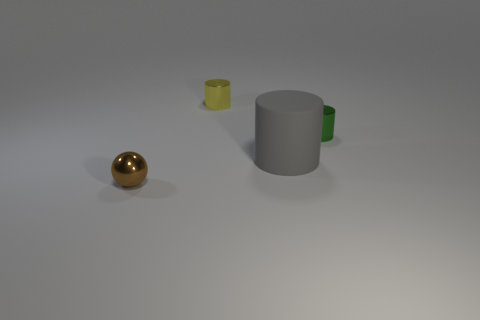Add 1 big gray rubber cylinders. How many objects exist? 5 Subtract all balls. How many objects are left? 3 Subtract 0 red blocks. How many objects are left? 4 Subtract all cyan shiny balls. Subtract all metallic spheres. How many objects are left? 3 Add 3 big gray things. How many big gray things are left? 4 Add 1 big gray rubber things. How many big gray rubber things exist? 2 